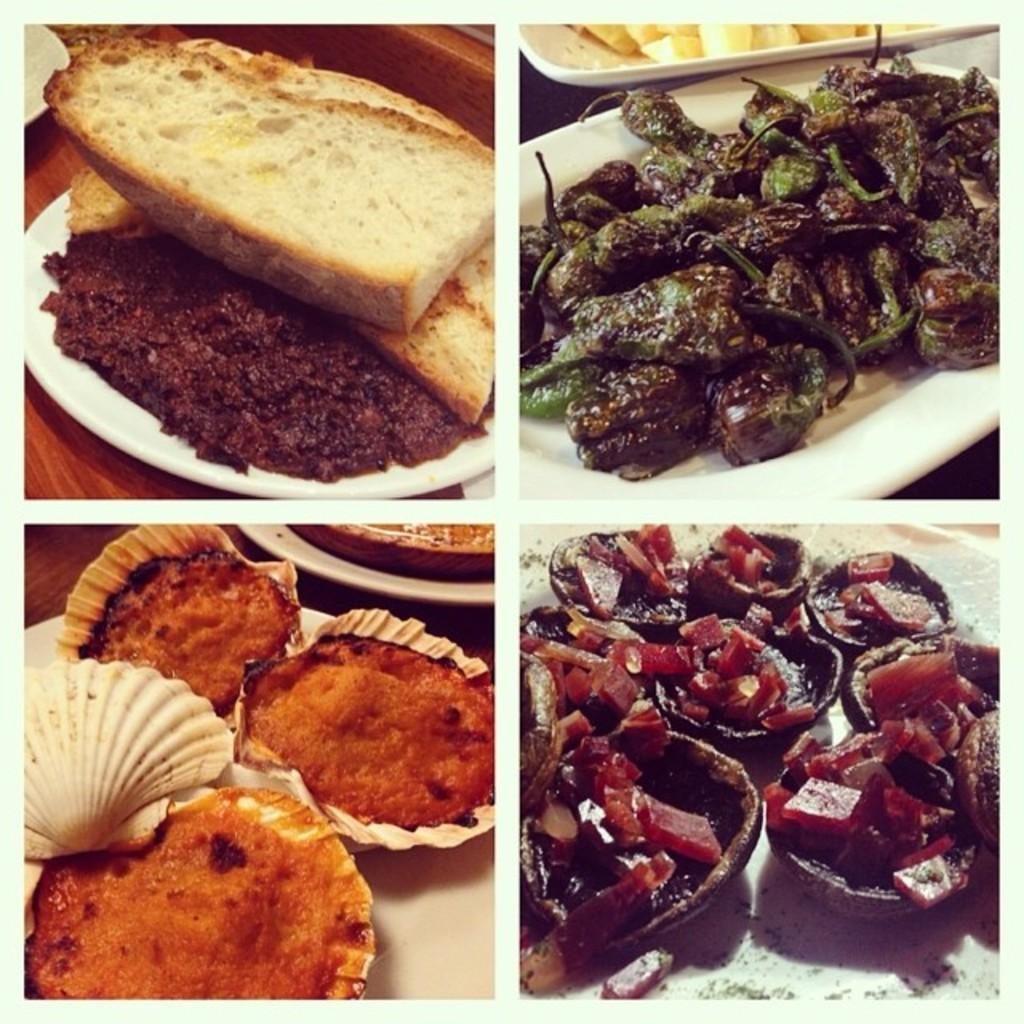What type of picture is in the image? There is a collage picture in the image. What is depicted in the collage picture? The collage picture contains food items. How are the food items arranged in the collage picture? The food items are in plates. Can you see any harmony in the sand depicted in the image? There is no sand present in the image; it features a collage picture with food items in plates. 